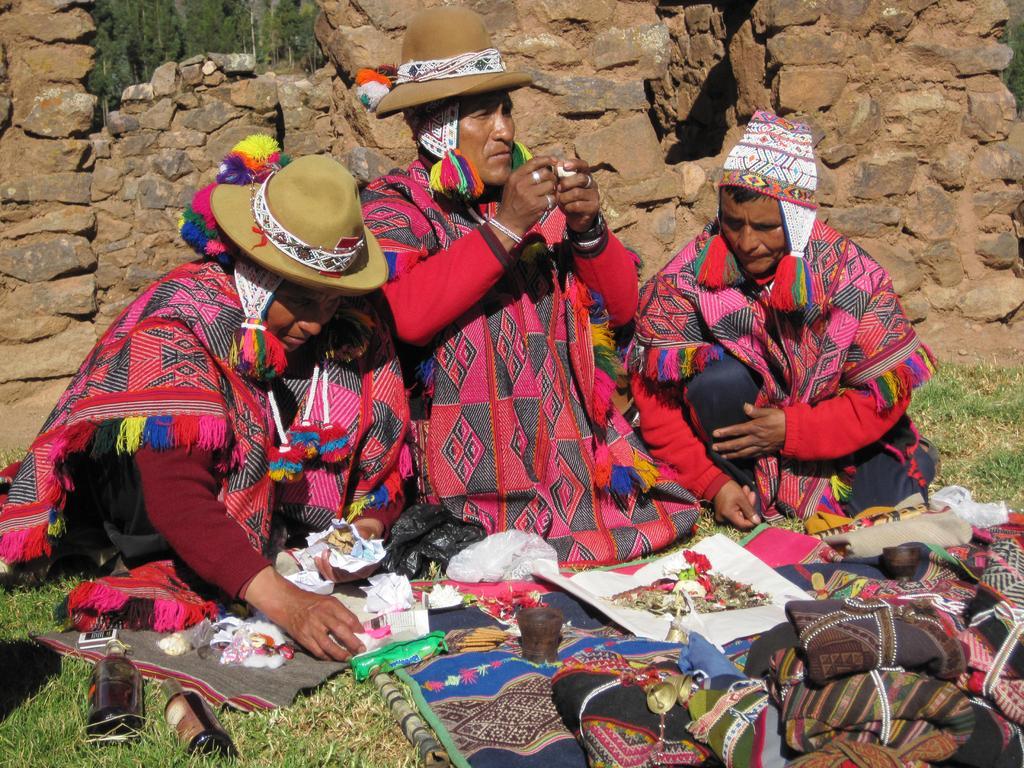Could you give a brief overview of what you see in this image? In the foreground of the picture there are clothes and some objects. On the left there are bottles. In the center of the picture there are three people sitting, behind them there is a stone wall. In the background there are trees. It is sunny. 